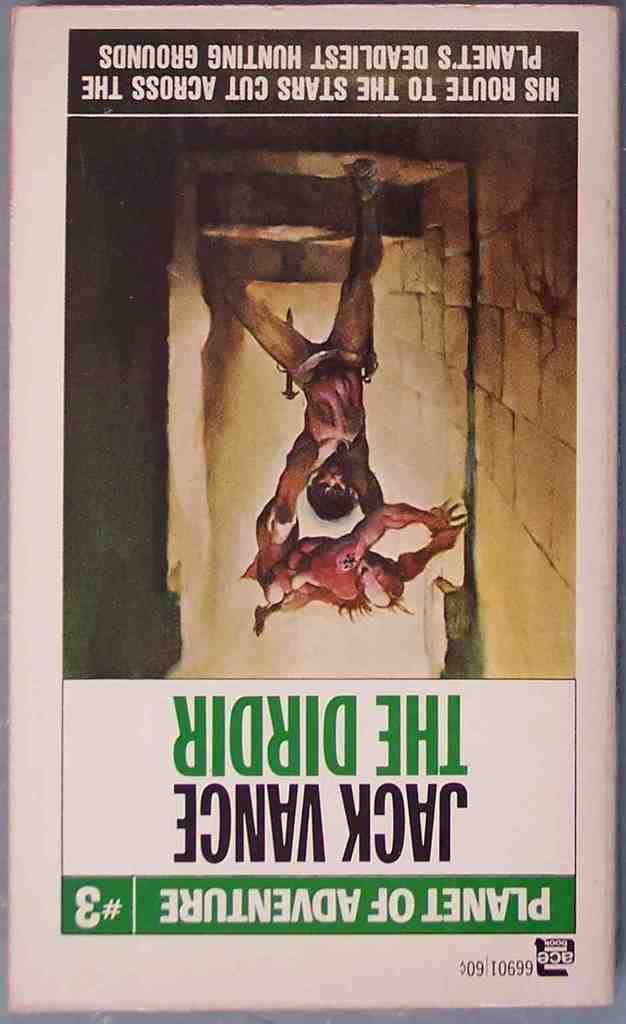What is the planet of?
Give a very brief answer. Adventure. What is the name in black at the bottom?
Provide a succinct answer. Jack vance. 